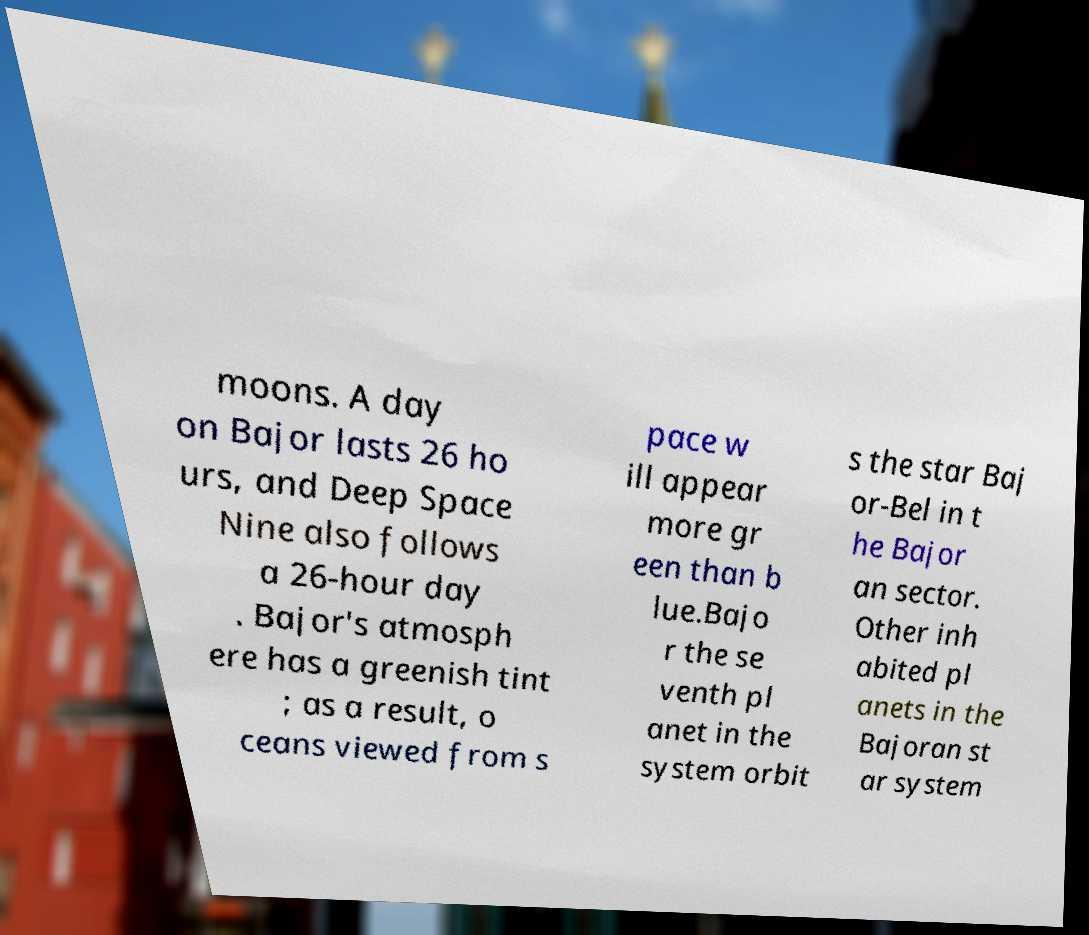What messages or text are displayed in this image? I need them in a readable, typed format. moons. A day on Bajor lasts 26 ho urs, and Deep Space Nine also follows a 26-hour day . Bajor's atmosph ere has a greenish tint ; as a result, o ceans viewed from s pace w ill appear more gr een than b lue.Bajo r the se venth pl anet in the system orbit s the star Baj or-Bel in t he Bajor an sector. Other inh abited pl anets in the Bajoran st ar system 